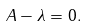<formula> <loc_0><loc_0><loc_500><loc_500>A - \lambda = 0 .</formula> 